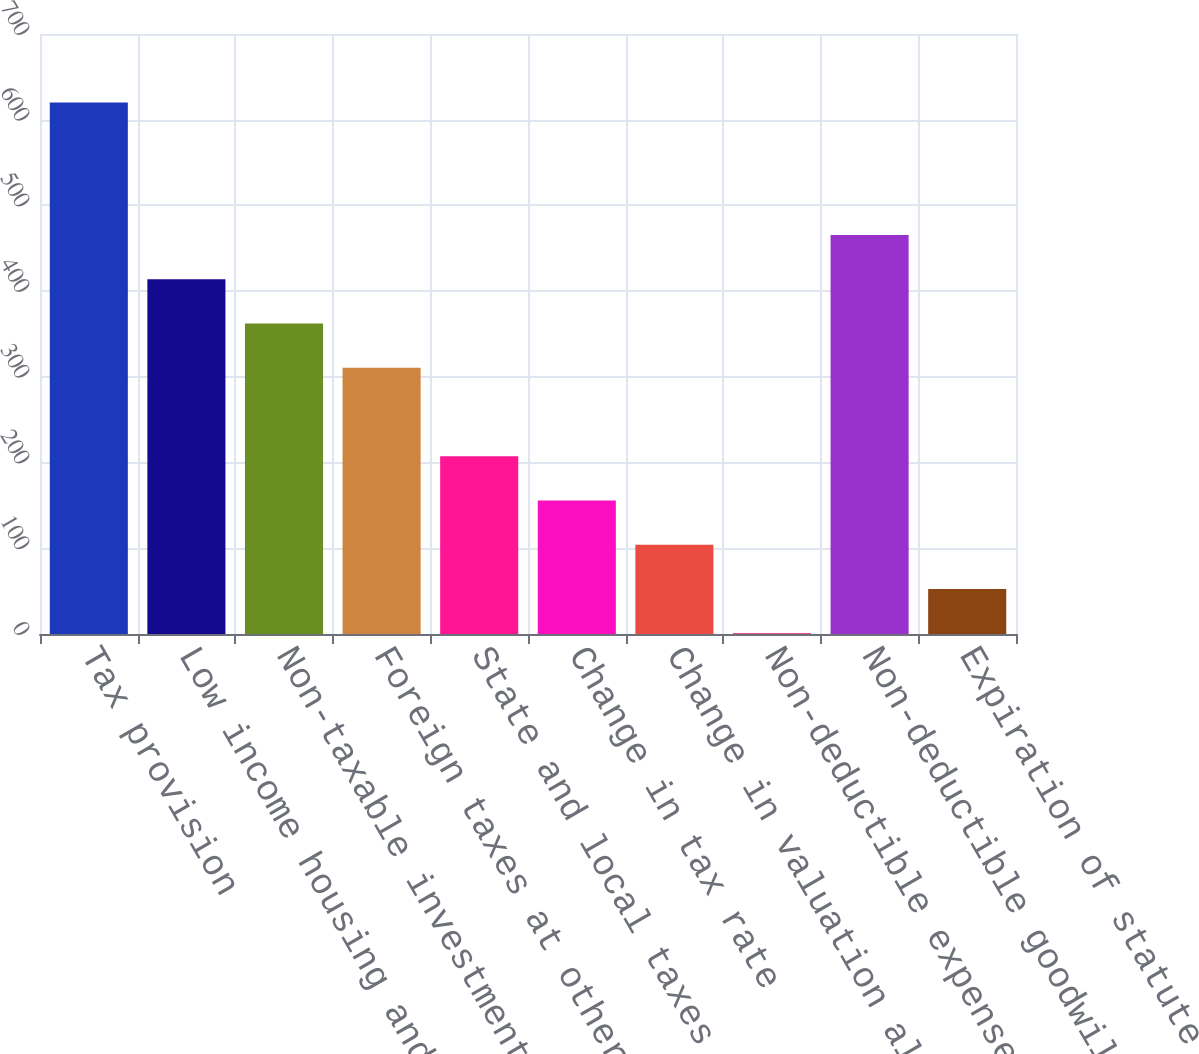<chart> <loc_0><loc_0><loc_500><loc_500><bar_chart><fcel>Tax provision<fcel>Low income housing and other<fcel>Non-taxable investment income<fcel>Foreign taxes at other than US<fcel>State and local taxes<fcel>Change in tax rate<fcel>Change in valuation allowance<fcel>Non-deductible expenses<fcel>Non-deductible goodwill<fcel>Expiration of statute of<nl><fcel>620.2<fcel>413.8<fcel>362.2<fcel>310.6<fcel>207.4<fcel>155.8<fcel>104.2<fcel>1<fcel>465.4<fcel>52.6<nl></chart> 